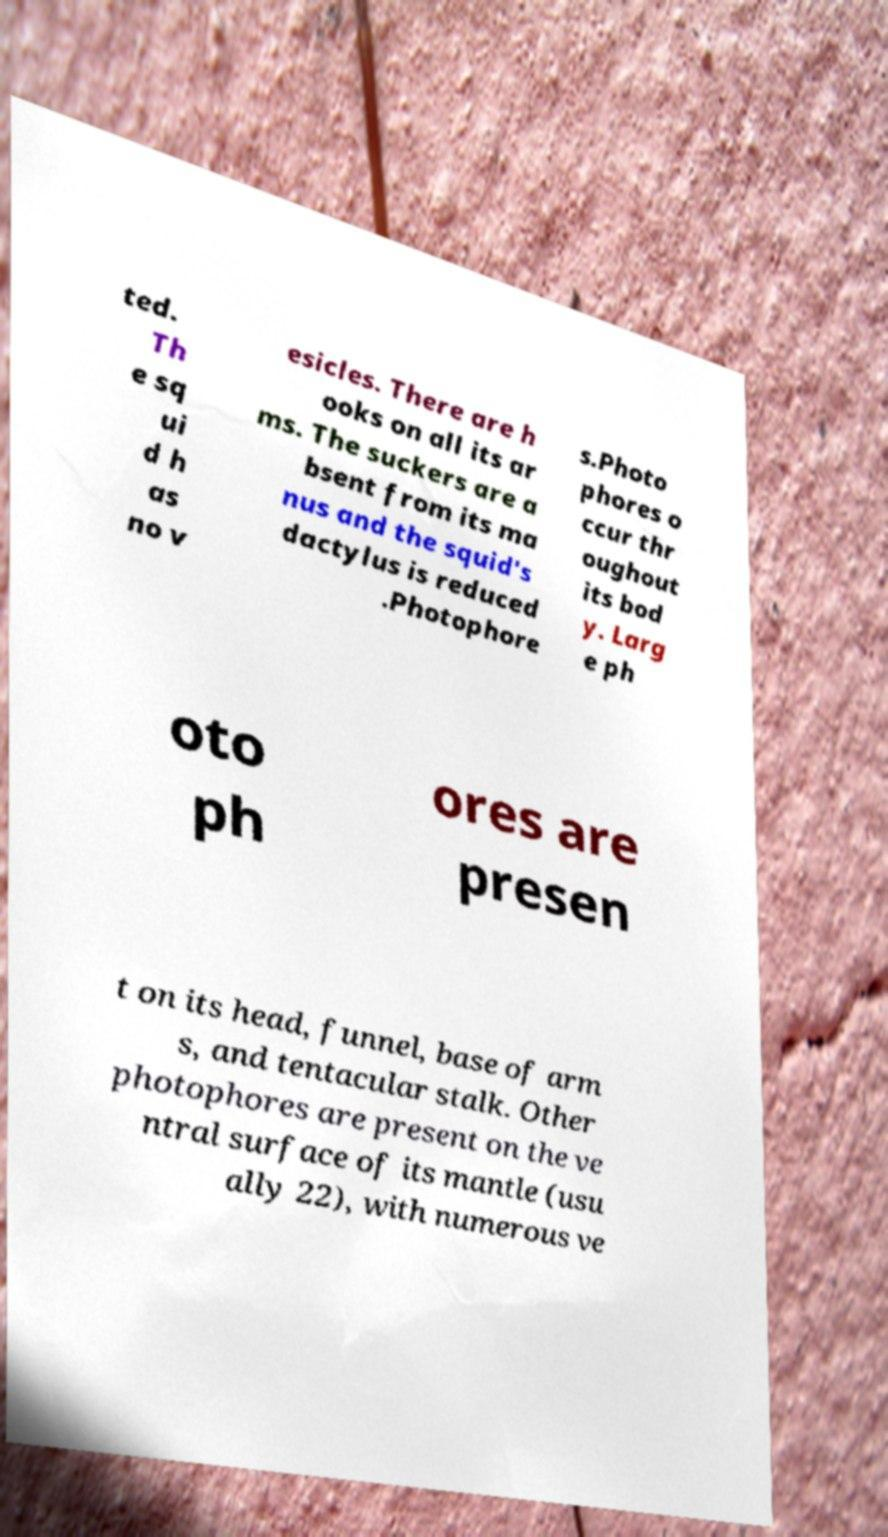What messages or text are displayed in this image? I need them in a readable, typed format. ted. Th e sq ui d h as no v esicles. There are h ooks on all its ar ms. The suckers are a bsent from its ma nus and the squid's dactylus is reduced .Photophore s.Photo phores o ccur thr oughout its bod y. Larg e ph oto ph ores are presen t on its head, funnel, base of arm s, and tentacular stalk. Other photophores are present on the ve ntral surface of its mantle (usu ally 22), with numerous ve 